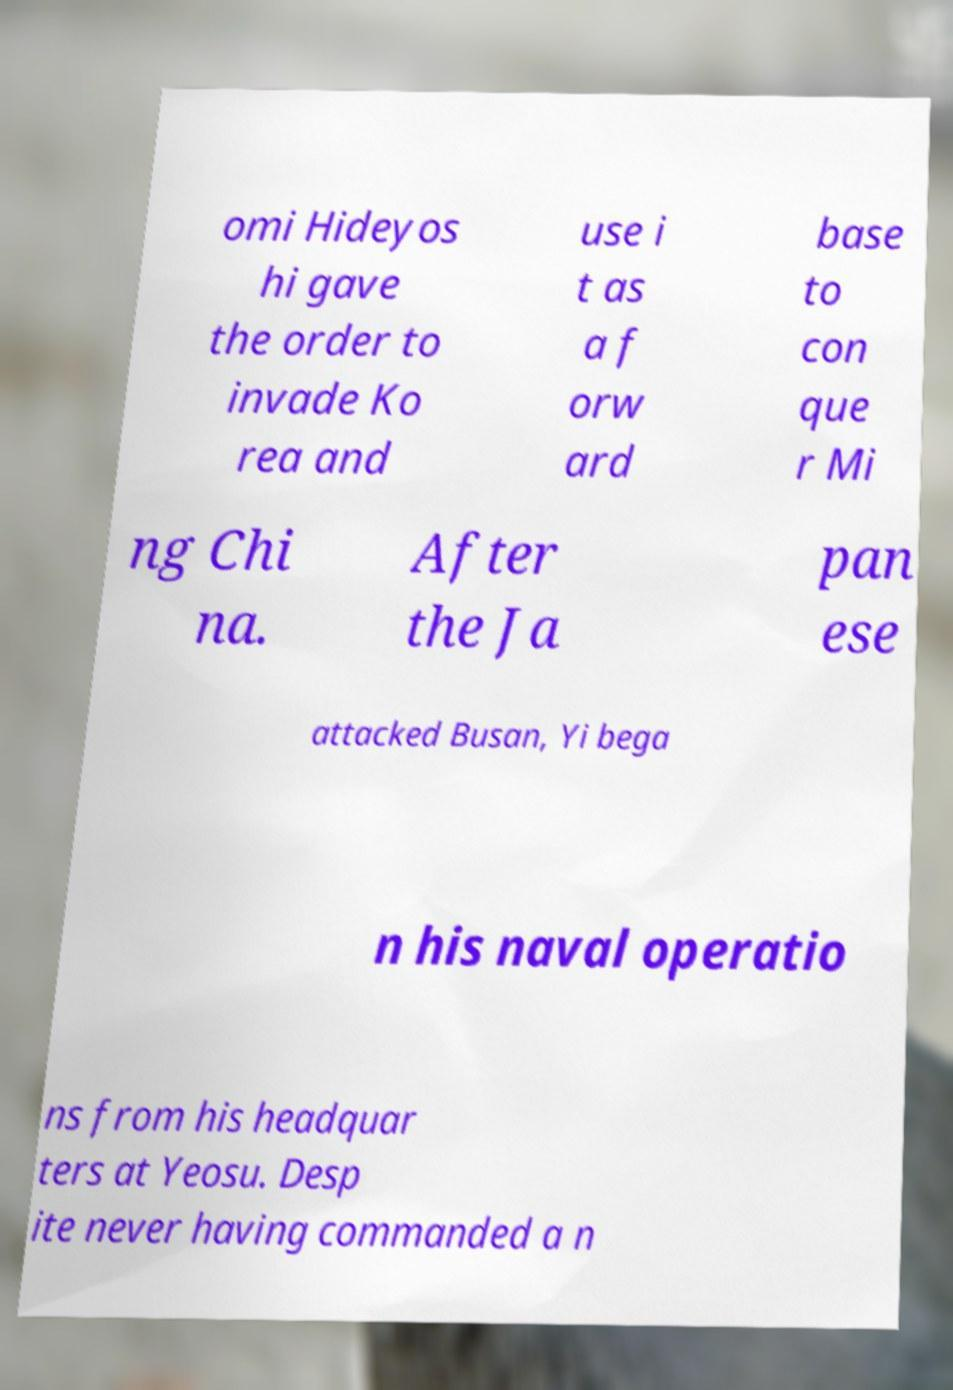Please read and relay the text visible in this image. What does it say? omi Hideyos hi gave the order to invade Ko rea and use i t as a f orw ard base to con que r Mi ng Chi na. After the Ja pan ese attacked Busan, Yi bega n his naval operatio ns from his headquar ters at Yeosu. Desp ite never having commanded a n 